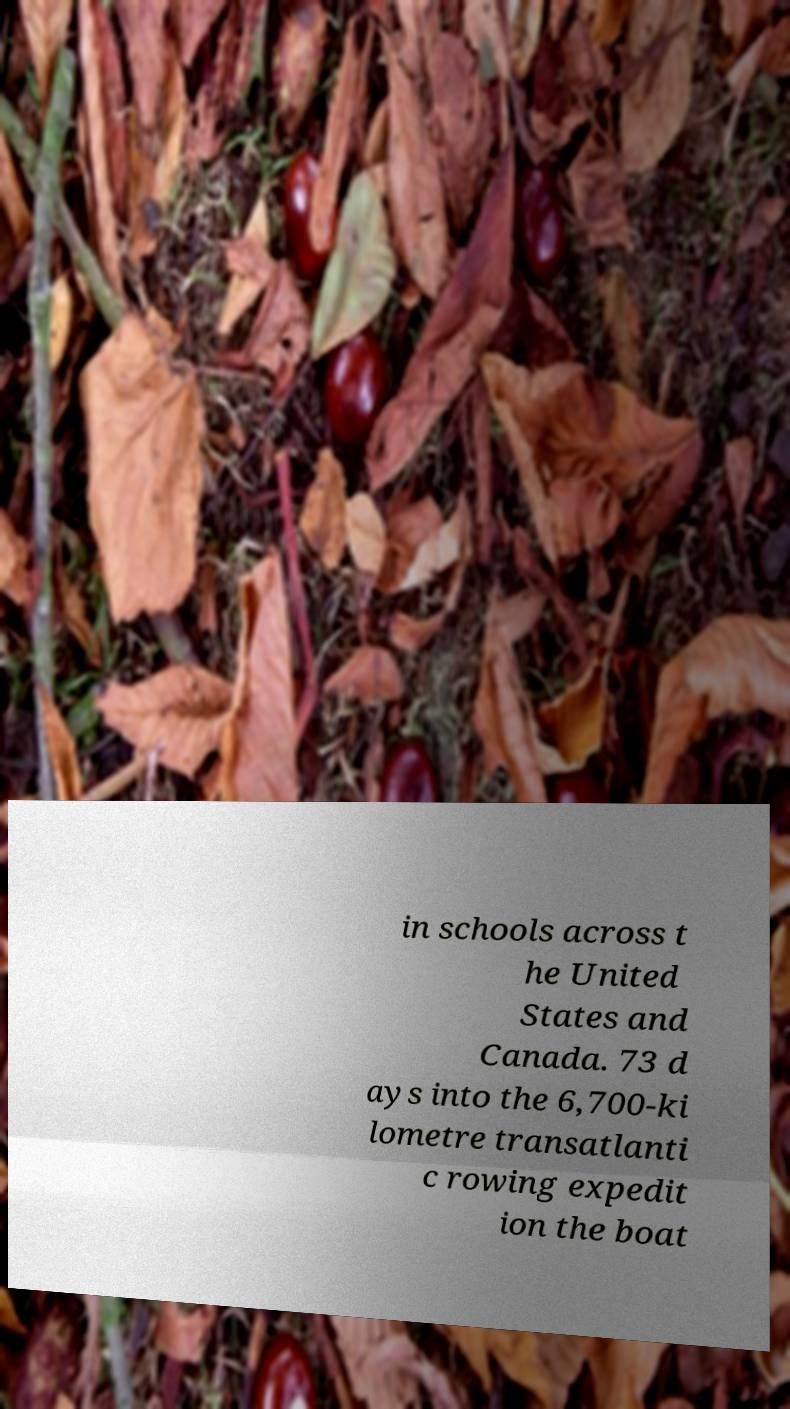Can you read and provide the text displayed in the image?This photo seems to have some interesting text. Can you extract and type it out for me? in schools across t he United States and Canada. 73 d ays into the 6,700-ki lometre transatlanti c rowing expedit ion the boat 